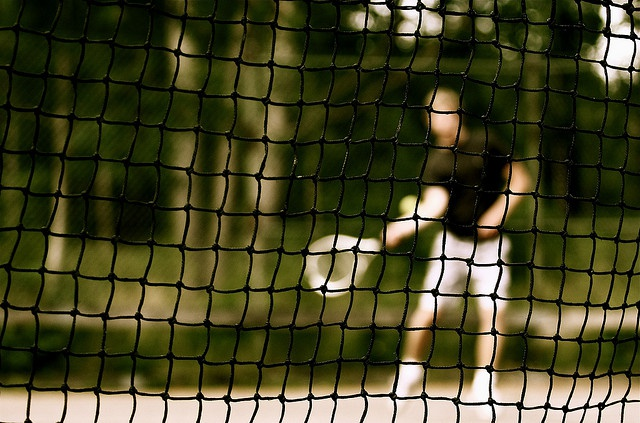Describe the objects in this image and their specific colors. I can see people in darkgreen, black, white, olive, and tan tones, tennis racket in darkgreen, tan, white, and black tones, and sports ball in darkgreen, khaki, olive, and black tones in this image. 